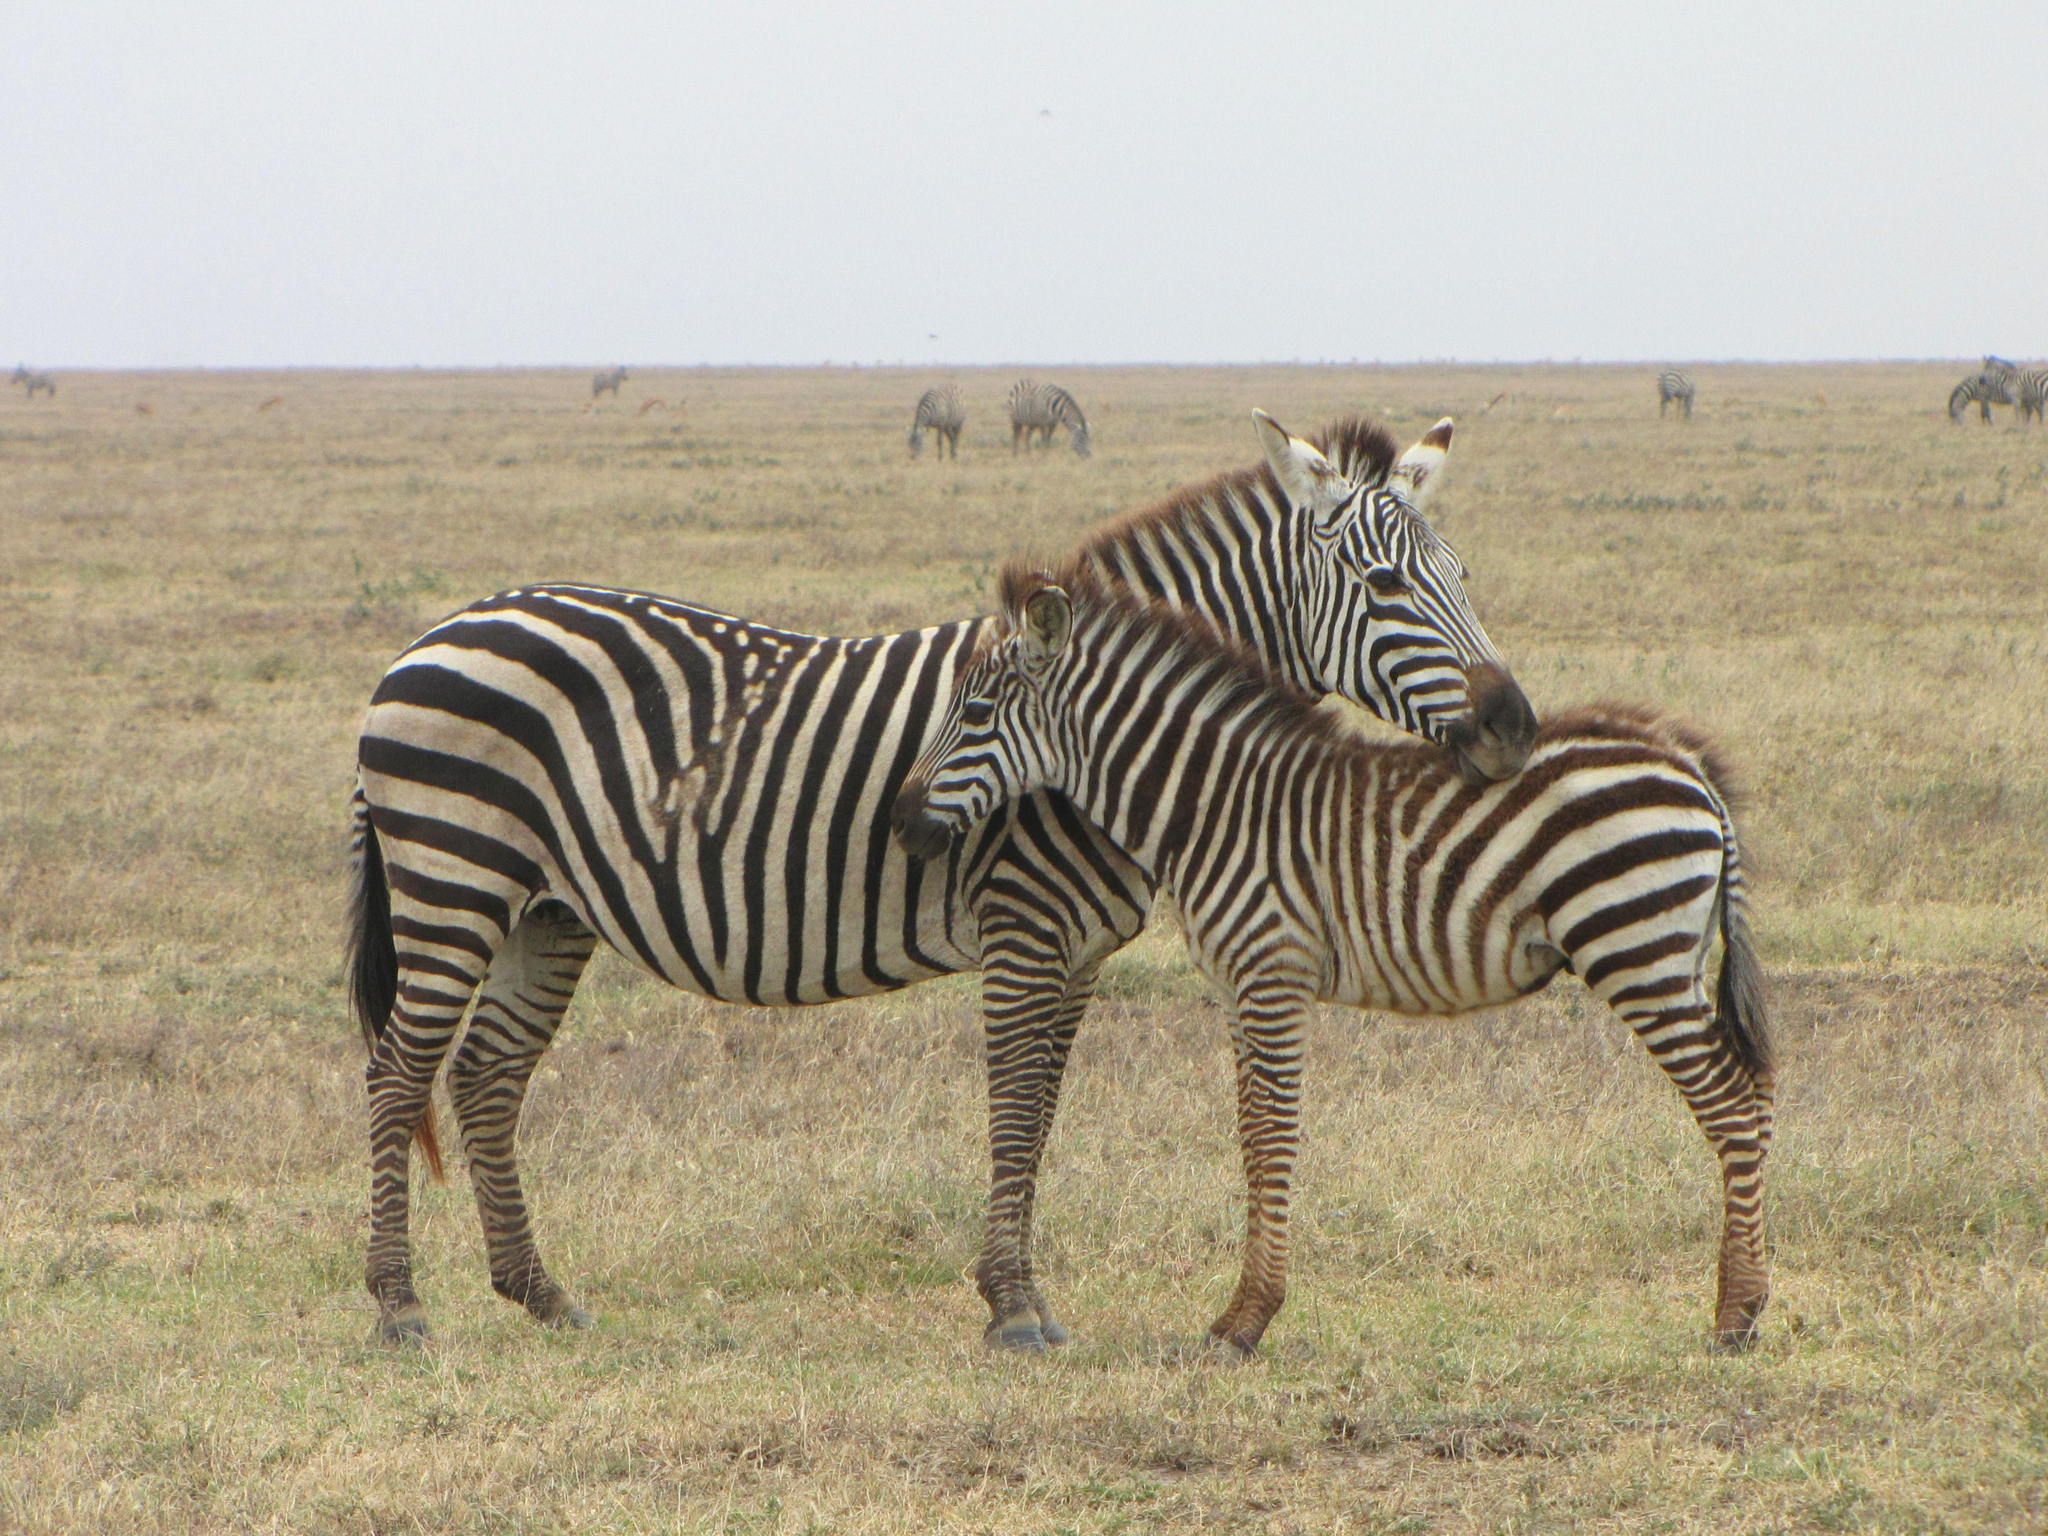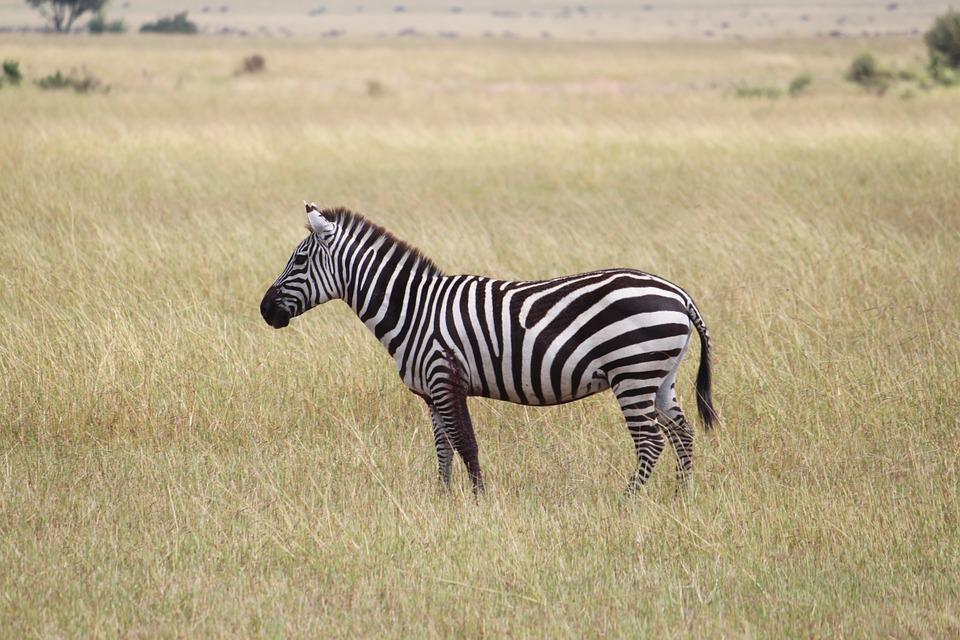The first image is the image on the left, the second image is the image on the right. Considering the images on both sides, is "Here we have exactly three zebras." valid? Answer yes or no. Yes. The first image is the image on the left, the second image is the image on the right. For the images shown, is this caption "There is a single zebra in one image." true? Answer yes or no. Yes. 